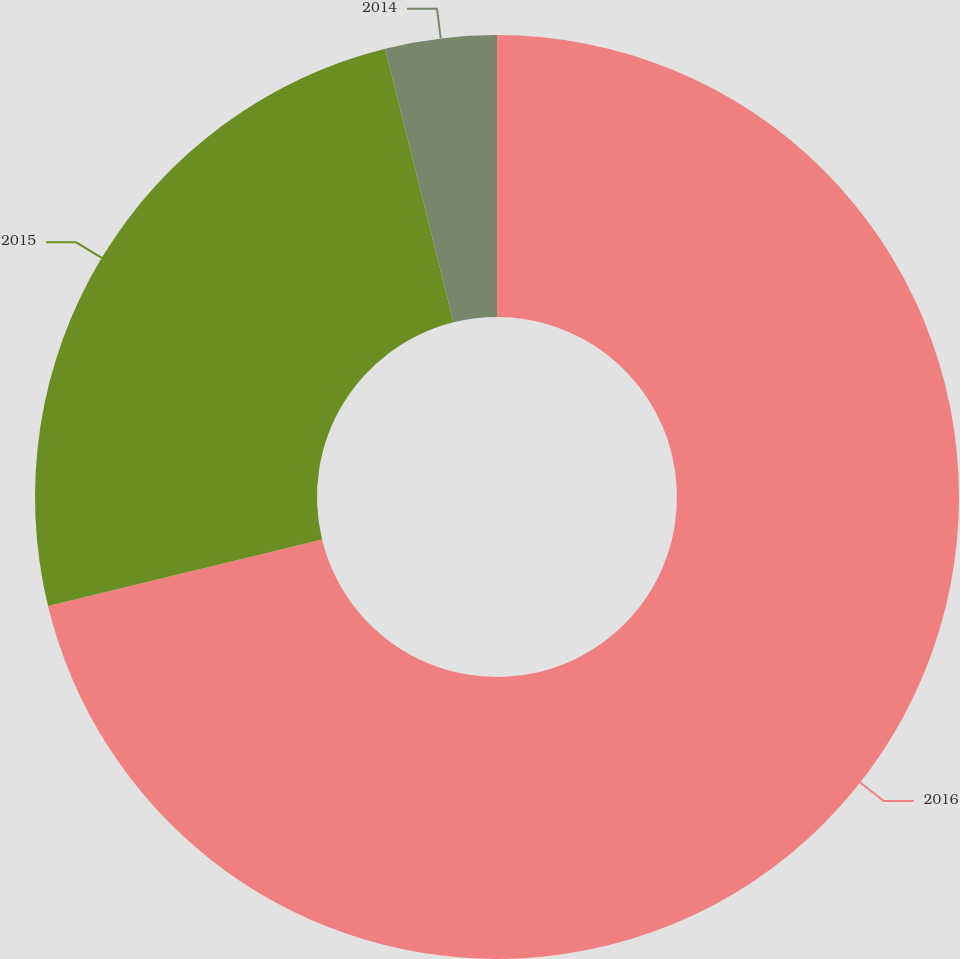Convert chart to OTSL. <chart><loc_0><loc_0><loc_500><loc_500><pie_chart><fcel>2016<fcel>2015<fcel>2014<nl><fcel>71.21%<fcel>24.9%<fcel>3.89%<nl></chart> 